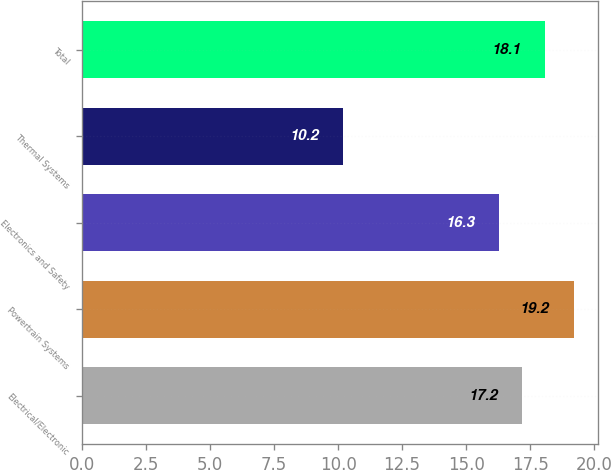Convert chart. <chart><loc_0><loc_0><loc_500><loc_500><bar_chart><fcel>Electrical/Electronic<fcel>Powertrain Systems<fcel>Electronics and Safety<fcel>Thermal Systems<fcel>Total<nl><fcel>17.2<fcel>19.2<fcel>16.3<fcel>10.2<fcel>18.1<nl></chart> 